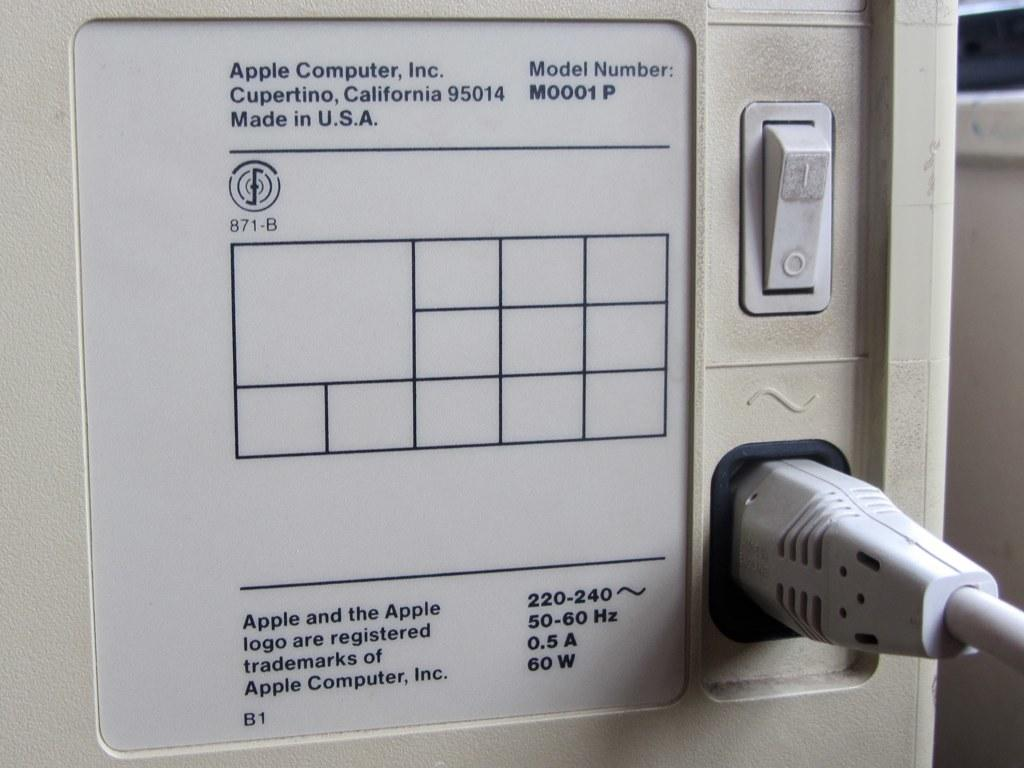What is the main object in the image? There is a machine in the image. What can be found on the machine? The machine has a plug and a switch. Is there anything attached to the machine? Yes, there is a board attached to the machine. What is written on the board? There is text on the board. How many hats are visible on the machine in the image? There are no hats present on the machine in the image. What type of war is depicted in the image? There is no depiction of war in the image; it features a machine with a plug, switch, and board with text. 